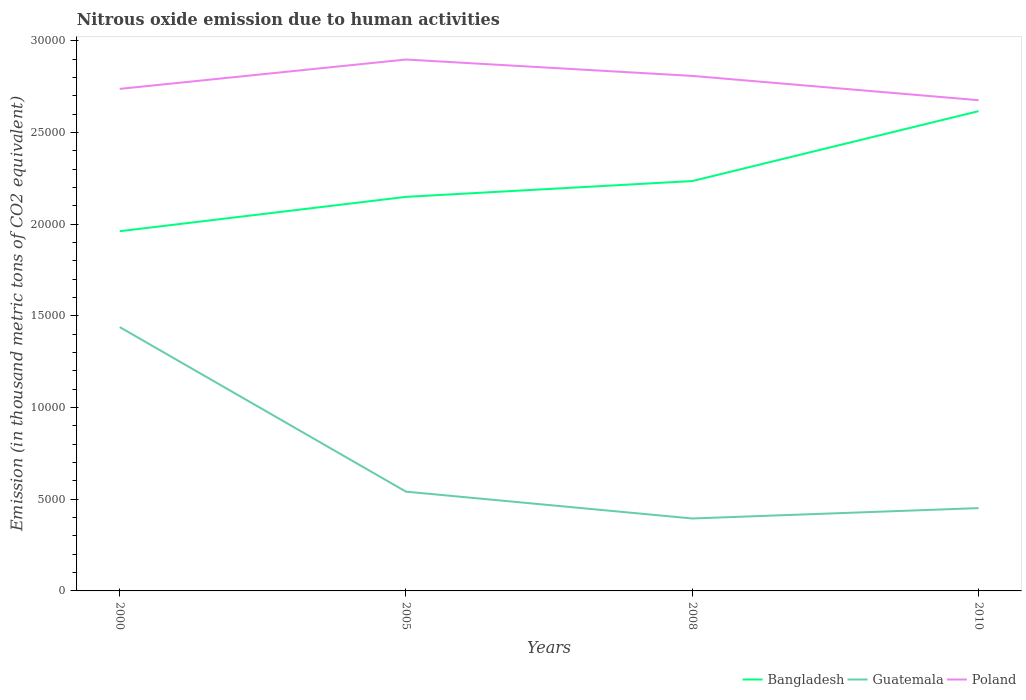How many different coloured lines are there?
Ensure brevity in your answer.  3. Is the number of lines equal to the number of legend labels?
Provide a short and direct response. Yes. Across all years, what is the maximum amount of nitrous oxide emitted in Poland?
Provide a short and direct response. 2.68e+04. In which year was the amount of nitrous oxide emitted in Bangladesh maximum?
Ensure brevity in your answer.  2000. What is the total amount of nitrous oxide emitted in Bangladesh in the graph?
Give a very brief answer. -6545.4. What is the difference between the highest and the second highest amount of nitrous oxide emitted in Bangladesh?
Ensure brevity in your answer.  6545.4. What is the difference between the highest and the lowest amount of nitrous oxide emitted in Guatemala?
Your response must be concise. 1. How many lines are there?
Provide a short and direct response. 3. What is the difference between two consecutive major ticks on the Y-axis?
Your answer should be very brief. 5000. Does the graph contain any zero values?
Keep it short and to the point. No. How many legend labels are there?
Offer a very short reply. 3. What is the title of the graph?
Ensure brevity in your answer.  Nitrous oxide emission due to human activities. Does "Middle East & North Africa (all income levels)" appear as one of the legend labels in the graph?
Provide a succinct answer. No. What is the label or title of the Y-axis?
Make the answer very short. Emission (in thousand metric tons of CO2 equivalent). What is the Emission (in thousand metric tons of CO2 equivalent) in Bangladesh in 2000?
Your answer should be compact. 1.96e+04. What is the Emission (in thousand metric tons of CO2 equivalent) in Guatemala in 2000?
Give a very brief answer. 1.44e+04. What is the Emission (in thousand metric tons of CO2 equivalent) in Poland in 2000?
Offer a very short reply. 2.74e+04. What is the Emission (in thousand metric tons of CO2 equivalent) of Bangladesh in 2005?
Provide a succinct answer. 2.15e+04. What is the Emission (in thousand metric tons of CO2 equivalent) in Guatemala in 2005?
Give a very brief answer. 5413.1. What is the Emission (in thousand metric tons of CO2 equivalent) in Poland in 2005?
Your response must be concise. 2.90e+04. What is the Emission (in thousand metric tons of CO2 equivalent) in Bangladesh in 2008?
Offer a terse response. 2.23e+04. What is the Emission (in thousand metric tons of CO2 equivalent) of Guatemala in 2008?
Give a very brief answer. 3950.2. What is the Emission (in thousand metric tons of CO2 equivalent) in Poland in 2008?
Your response must be concise. 2.81e+04. What is the Emission (in thousand metric tons of CO2 equivalent) in Bangladesh in 2010?
Offer a terse response. 2.62e+04. What is the Emission (in thousand metric tons of CO2 equivalent) in Guatemala in 2010?
Ensure brevity in your answer.  4515.5. What is the Emission (in thousand metric tons of CO2 equivalent) of Poland in 2010?
Your answer should be very brief. 2.68e+04. Across all years, what is the maximum Emission (in thousand metric tons of CO2 equivalent) in Bangladesh?
Ensure brevity in your answer.  2.62e+04. Across all years, what is the maximum Emission (in thousand metric tons of CO2 equivalent) of Guatemala?
Make the answer very short. 1.44e+04. Across all years, what is the maximum Emission (in thousand metric tons of CO2 equivalent) in Poland?
Offer a terse response. 2.90e+04. Across all years, what is the minimum Emission (in thousand metric tons of CO2 equivalent) of Bangladesh?
Your answer should be compact. 1.96e+04. Across all years, what is the minimum Emission (in thousand metric tons of CO2 equivalent) of Guatemala?
Your answer should be very brief. 3950.2. Across all years, what is the minimum Emission (in thousand metric tons of CO2 equivalent) in Poland?
Your answer should be compact. 2.68e+04. What is the total Emission (in thousand metric tons of CO2 equivalent) in Bangladesh in the graph?
Offer a terse response. 8.96e+04. What is the total Emission (in thousand metric tons of CO2 equivalent) of Guatemala in the graph?
Give a very brief answer. 2.83e+04. What is the total Emission (in thousand metric tons of CO2 equivalent) of Poland in the graph?
Offer a very short reply. 1.11e+05. What is the difference between the Emission (in thousand metric tons of CO2 equivalent) of Bangladesh in 2000 and that in 2005?
Give a very brief answer. -1872.5. What is the difference between the Emission (in thousand metric tons of CO2 equivalent) in Guatemala in 2000 and that in 2005?
Provide a short and direct response. 8972.6. What is the difference between the Emission (in thousand metric tons of CO2 equivalent) in Poland in 2000 and that in 2005?
Keep it short and to the point. -1600.6. What is the difference between the Emission (in thousand metric tons of CO2 equivalent) in Bangladesh in 2000 and that in 2008?
Offer a terse response. -2734.2. What is the difference between the Emission (in thousand metric tons of CO2 equivalent) of Guatemala in 2000 and that in 2008?
Offer a very short reply. 1.04e+04. What is the difference between the Emission (in thousand metric tons of CO2 equivalent) in Poland in 2000 and that in 2008?
Keep it short and to the point. -707.1. What is the difference between the Emission (in thousand metric tons of CO2 equivalent) in Bangladesh in 2000 and that in 2010?
Your answer should be compact. -6545.4. What is the difference between the Emission (in thousand metric tons of CO2 equivalent) of Guatemala in 2000 and that in 2010?
Provide a short and direct response. 9870.2. What is the difference between the Emission (in thousand metric tons of CO2 equivalent) of Poland in 2000 and that in 2010?
Keep it short and to the point. 617.4. What is the difference between the Emission (in thousand metric tons of CO2 equivalent) of Bangladesh in 2005 and that in 2008?
Keep it short and to the point. -861.7. What is the difference between the Emission (in thousand metric tons of CO2 equivalent) of Guatemala in 2005 and that in 2008?
Offer a very short reply. 1462.9. What is the difference between the Emission (in thousand metric tons of CO2 equivalent) in Poland in 2005 and that in 2008?
Offer a terse response. 893.5. What is the difference between the Emission (in thousand metric tons of CO2 equivalent) in Bangladesh in 2005 and that in 2010?
Provide a succinct answer. -4672.9. What is the difference between the Emission (in thousand metric tons of CO2 equivalent) of Guatemala in 2005 and that in 2010?
Your answer should be compact. 897.6. What is the difference between the Emission (in thousand metric tons of CO2 equivalent) of Poland in 2005 and that in 2010?
Make the answer very short. 2218. What is the difference between the Emission (in thousand metric tons of CO2 equivalent) of Bangladesh in 2008 and that in 2010?
Provide a succinct answer. -3811.2. What is the difference between the Emission (in thousand metric tons of CO2 equivalent) in Guatemala in 2008 and that in 2010?
Keep it short and to the point. -565.3. What is the difference between the Emission (in thousand metric tons of CO2 equivalent) of Poland in 2008 and that in 2010?
Ensure brevity in your answer.  1324.5. What is the difference between the Emission (in thousand metric tons of CO2 equivalent) of Bangladesh in 2000 and the Emission (in thousand metric tons of CO2 equivalent) of Guatemala in 2005?
Your answer should be very brief. 1.42e+04. What is the difference between the Emission (in thousand metric tons of CO2 equivalent) of Bangladesh in 2000 and the Emission (in thousand metric tons of CO2 equivalent) of Poland in 2005?
Offer a very short reply. -9361.3. What is the difference between the Emission (in thousand metric tons of CO2 equivalent) of Guatemala in 2000 and the Emission (in thousand metric tons of CO2 equivalent) of Poland in 2005?
Provide a short and direct response. -1.46e+04. What is the difference between the Emission (in thousand metric tons of CO2 equivalent) of Bangladesh in 2000 and the Emission (in thousand metric tons of CO2 equivalent) of Guatemala in 2008?
Your answer should be compact. 1.57e+04. What is the difference between the Emission (in thousand metric tons of CO2 equivalent) in Bangladesh in 2000 and the Emission (in thousand metric tons of CO2 equivalent) in Poland in 2008?
Offer a very short reply. -8467.8. What is the difference between the Emission (in thousand metric tons of CO2 equivalent) of Guatemala in 2000 and the Emission (in thousand metric tons of CO2 equivalent) of Poland in 2008?
Provide a short and direct response. -1.37e+04. What is the difference between the Emission (in thousand metric tons of CO2 equivalent) in Bangladesh in 2000 and the Emission (in thousand metric tons of CO2 equivalent) in Guatemala in 2010?
Ensure brevity in your answer.  1.51e+04. What is the difference between the Emission (in thousand metric tons of CO2 equivalent) of Bangladesh in 2000 and the Emission (in thousand metric tons of CO2 equivalent) of Poland in 2010?
Provide a short and direct response. -7143.3. What is the difference between the Emission (in thousand metric tons of CO2 equivalent) of Guatemala in 2000 and the Emission (in thousand metric tons of CO2 equivalent) of Poland in 2010?
Provide a succinct answer. -1.24e+04. What is the difference between the Emission (in thousand metric tons of CO2 equivalent) in Bangladesh in 2005 and the Emission (in thousand metric tons of CO2 equivalent) in Guatemala in 2008?
Your answer should be compact. 1.75e+04. What is the difference between the Emission (in thousand metric tons of CO2 equivalent) of Bangladesh in 2005 and the Emission (in thousand metric tons of CO2 equivalent) of Poland in 2008?
Make the answer very short. -6595.3. What is the difference between the Emission (in thousand metric tons of CO2 equivalent) of Guatemala in 2005 and the Emission (in thousand metric tons of CO2 equivalent) of Poland in 2008?
Make the answer very short. -2.27e+04. What is the difference between the Emission (in thousand metric tons of CO2 equivalent) in Bangladesh in 2005 and the Emission (in thousand metric tons of CO2 equivalent) in Guatemala in 2010?
Ensure brevity in your answer.  1.70e+04. What is the difference between the Emission (in thousand metric tons of CO2 equivalent) of Bangladesh in 2005 and the Emission (in thousand metric tons of CO2 equivalent) of Poland in 2010?
Ensure brevity in your answer.  -5270.8. What is the difference between the Emission (in thousand metric tons of CO2 equivalent) in Guatemala in 2005 and the Emission (in thousand metric tons of CO2 equivalent) in Poland in 2010?
Make the answer very short. -2.13e+04. What is the difference between the Emission (in thousand metric tons of CO2 equivalent) in Bangladesh in 2008 and the Emission (in thousand metric tons of CO2 equivalent) in Guatemala in 2010?
Provide a succinct answer. 1.78e+04. What is the difference between the Emission (in thousand metric tons of CO2 equivalent) in Bangladesh in 2008 and the Emission (in thousand metric tons of CO2 equivalent) in Poland in 2010?
Give a very brief answer. -4409.1. What is the difference between the Emission (in thousand metric tons of CO2 equivalent) in Guatemala in 2008 and the Emission (in thousand metric tons of CO2 equivalent) in Poland in 2010?
Offer a very short reply. -2.28e+04. What is the average Emission (in thousand metric tons of CO2 equivalent) of Bangladesh per year?
Your response must be concise. 2.24e+04. What is the average Emission (in thousand metric tons of CO2 equivalent) in Guatemala per year?
Provide a short and direct response. 7066.12. What is the average Emission (in thousand metric tons of CO2 equivalent) in Poland per year?
Offer a terse response. 2.78e+04. In the year 2000, what is the difference between the Emission (in thousand metric tons of CO2 equivalent) of Bangladesh and Emission (in thousand metric tons of CO2 equivalent) of Guatemala?
Ensure brevity in your answer.  5228.5. In the year 2000, what is the difference between the Emission (in thousand metric tons of CO2 equivalent) in Bangladesh and Emission (in thousand metric tons of CO2 equivalent) in Poland?
Your answer should be compact. -7760.7. In the year 2000, what is the difference between the Emission (in thousand metric tons of CO2 equivalent) of Guatemala and Emission (in thousand metric tons of CO2 equivalent) of Poland?
Offer a very short reply. -1.30e+04. In the year 2005, what is the difference between the Emission (in thousand metric tons of CO2 equivalent) in Bangladesh and Emission (in thousand metric tons of CO2 equivalent) in Guatemala?
Ensure brevity in your answer.  1.61e+04. In the year 2005, what is the difference between the Emission (in thousand metric tons of CO2 equivalent) in Bangladesh and Emission (in thousand metric tons of CO2 equivalent) in Poland?
Provide a succinct answer. -7488.8. In the year 2005, what is the difference between the Emission (in thousand metric tons of CO2 equivalent) of Guatemala and Emission (in thousand metric tons of CO2 equivalent) of Poland?
Your answer should be very brief. -2.36e+04. In the year 2008, what is the difference between the Emission (in thousand metric tons of CO2 equivalent) in Bangladesh and Emission (in thousand metric tons of CO2 equivalent) in Guatemala?
Keep it short and to the point. 1.84e+04. In the year 2008, what is the difference between the Emission (in thousand metric tons of CO2 equivalent) in Bangladesh and Emission (in thousand metric tons of CO2 equivalent) in Poland?
Give a very brief answer. -5733.6. In the year 2008, what is the difference between the Emission (in thousand metric tons of CO2 equivalent) of Guatemala and Emission (in thousand metric tons of CO2 equivalent) of Poland?
Your answer should be very brief. -2.41e+04. In the year 2010, what is the difference between the Emission (in thousand metric tons of CO2 equivalent) in Bangladesh and Emission (in thousand metric tons of CO2 equivalent) in Guatemala?
Provide a succinct answer. 2.16e+04. In the year 2010, what is the difference between the Emission (in thousand metric tons of CO2 equivalent) of Bangladesh and Emission (in thousand metric tons of CO2 equivalent) of Poland?
Your answer should be very brief. -597.9. In the year 2010, what is the difference between the Emission (in thousand metric tons of CO2 equivalent) in Guatemala and Emission (in thousand metric tons of CO2 equivalent) in Poland?
Provide a succinct answer. -2.22e+04. What is the ratio of the Emission (in thousand metric tons of CO2 equivalent) of Bangladesh in 2000 to that in 2005?
Your answer should be compact. 0.91. What is the ratio of the Emission (in thousand metric tons of CO2 equivalent) in Guatemala in 2000 to that in 2005?
Make the answer very short. 2.66. What is the ratio of the Emission (in thousand metric tons of CO2 equivalent) of Poland in 2000 to that in 2005?
Your response must be concise. 0.94. What is the ratio of the Emission (in thousand metric tons of CO2 equivalent) of Bangladesh in 2000 to that in 2008?
Your answer should be compact. 0.88. What is the ratio of the Emission (in thousand metric tons of CO2 equivalent) in Guatemala in 2000 to that in 2008?
Your response must be concise. 3.64. What is the ratio of the Emission (in thousand metric tons of CO2 equivalent) of Poland in 2000 to that in 2008?
Give a very brief answer. 0.97. What is the ratio of the Emission (in thousand metric tons of CO2 equivalent) in Bangladesh in 2000 to that in 2010?
Your answer should be compact. 0.75. What is the ratio of the Emission (in thousand metric tons of CO2 equivalent) of Guatemala in 2000 to that in 2010?
Provide a short and direct response. 3.19. What is the ratio of the Emission (in thousand metric tons of CO2 equivalent) in Poland in 2000 to that in 2010?
Provide a short and direct response. 1.02. What is the ratio of the Emission (in thousand metric tons of CO2 equivalent) in Bangladesh in 2005 to that in 2008?
Make the answer very short. 0.96. What is the ratio of the Emission (in thousand metric tons of CO2 equivalent) in Guatemala in 2005 to that in 2008?
Give a very brief answer. 1.37. What is the ratio of the Emission (in thousand metric tons of CO2 equivalent) of Poland in 2005 to that in 2008?
Offer a terse response. 1.03. What is the ratio of the Emission (in thousand metric tons of CO2 equivalent) in Bangladesh in 2005 to that in 2010?
Provide a succinct answer. 0.82. What is the ratio of the Emission (in thousand metric tons of CO2 equivalent) of Guatemala in 2005 to that in 2010?
Your response must be concise. 1.2. What is the ratio of the Emission (in thousand metric tons of CO2 equivalent) of Poland in 2005 to that in 2010?
Give a very brief answer. 1.08. What is the ratio of the Emission (in thousand metric tons of CO2 equivalent) of Bangladesh in 2008 to that in 2010?
Provide a succinct answer. 0.85. What is the ratio of the Emission (in thousand metric tons of CO2 equivalent) of Guatemala in 2008 to that in 2010?
Keep it short and to the point. 0.87. What is the ratio of the Emission (in thousand metric tons of CO2 equivalent) of Poland in 2008 to that in 2010?
Give a very brief answer. 1.05. What is the difference between the highest and the second highest Emission (in thousand metric tons of CO2 equivalent) of Bangladesh?
Keep it short and to the point. 3811.2. What is the difference between the highest and the second highest Emission (in thousand metric tons of CO2 equivalent) in Guatemala?
Your answer should be very brief. 8972.6. What is the difference between the highest and the second highest Emission (in thousand metric tons of CO2 equivalent) in Poland?
Make the answer very short. 893.5. What is the difference between the highest and the lowest Emission (in thousand metric tons of CO2 equivalent) of Bangladesh?
Provide a succinct answer. 6545.4. What is the difference between the highest and the lowest Emission (in thousand metric tons of CO2 equivalent) of Guatemala?
Provide a short and direct response. 1.04e+04. What is the difference between the highest and the lowest Emission (in thousand metric tons of CO2 equivalent) of Poland?
Offer a terse response. 2218. 